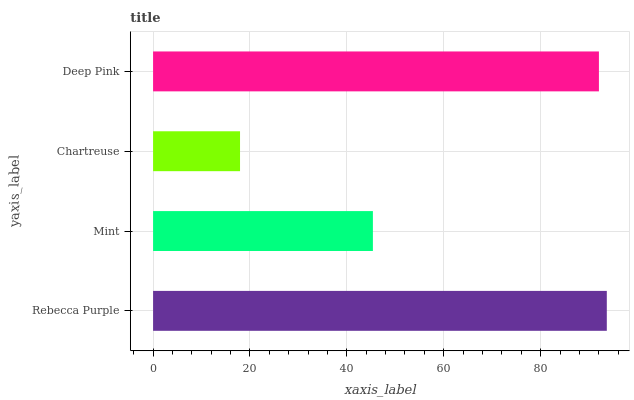Is Chartreuse the minimum?
Answer yes or no. Yes. Is Rebecca Purple the maximum?
Answer yes or no. Yes. Is Mint the minimum?
Answer yes or no. No. Is Mint the maximum?
Answer yes or no. No. Is Rebecca Purple greater than Mint?
Answer yes or no. Yes. Is Mint less than Rebecca Purple?
Answer yes or no. Yes. Is Mint greater than Rebecca Purple?
Answer yes or no. No. Is Rebecca Purple less than Mint?
Answer yes or no. No. Is Deep Pink the high median?
Answer yes or no. Yes. Is Mint the low median?
Answer yes or no. Yes. Is Rebecca Purple the high median?
Answer yes or no. No. Is Chartreuse the low median?
Answer yes or no. No. 